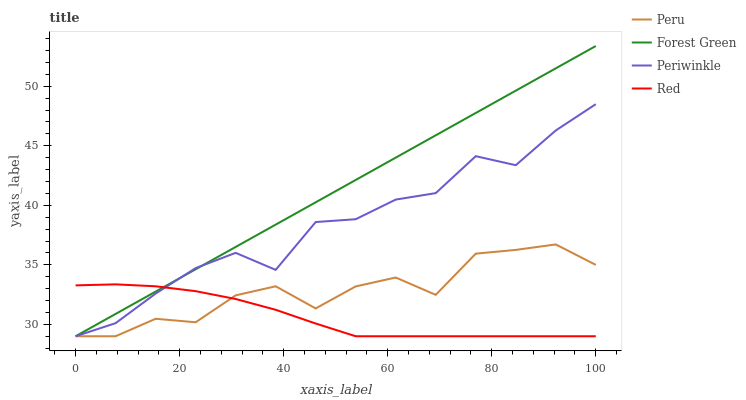Does Red have the minimum area under the curve?
Answer yes or no. Yes. Does Forest Green have the maximum area under the curve?
Answer yes or no. Yes. Does Periwinkle have the minimum area under the curve?
Answer yes or no. No. Does Periwinkle have the maximum area under the curve?
Answer yes or no. No. Is Forest Green the smoothest?
Answer yes or no. Yes. Is Periwinkle the roughest?
Answer yes or no. Yes. Is Red the smoothest?
Answer yes or no. No. Is Red the roughest?
Answer yes or no. No. Does Forest Green have the highest value?
Answer yes or no. Yes. Does Periwinkle have the highest value?
Answer yes or no. No. Does Peru intersect Forest Green?
Answer yes or no. Yes. Is Peru less than Forest Green?
Answer yes or no. No. Is Peru greater than Forest Green?
Answer yes or no. No. 